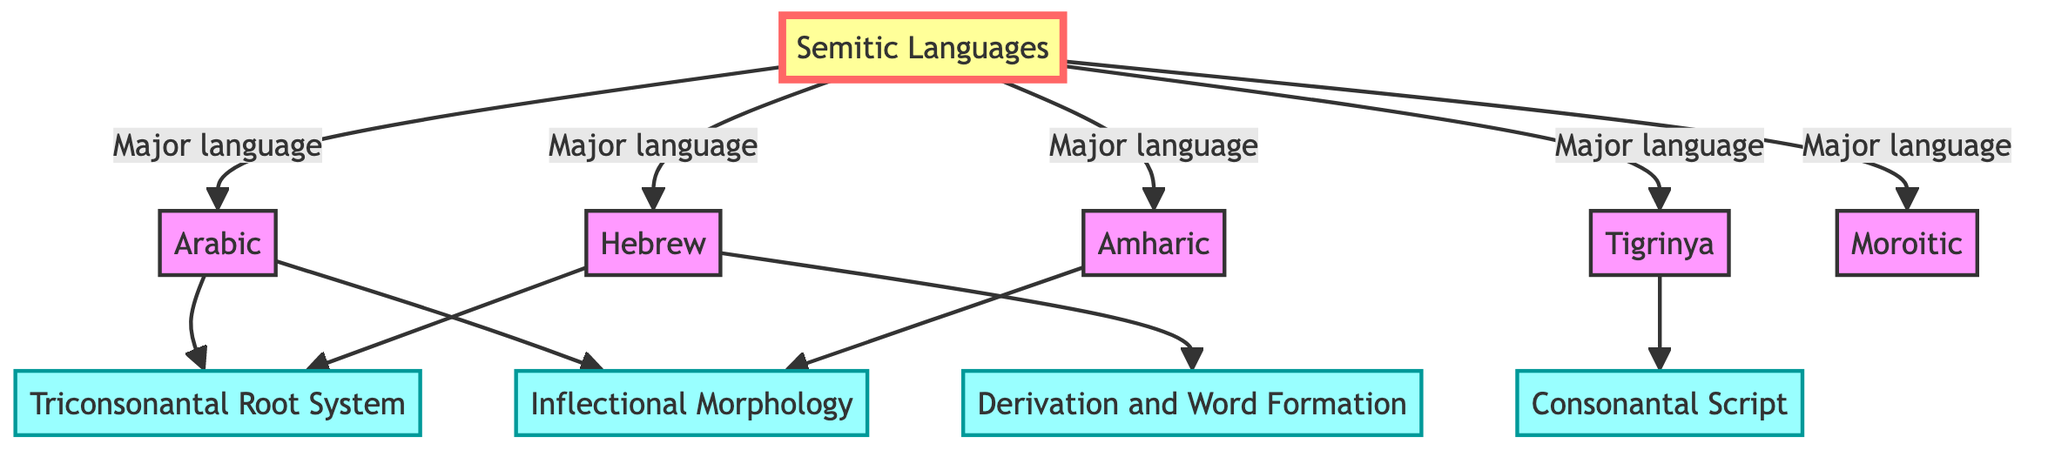What are the major Semitic languages depicted in the graph? The graph shows five major Semitic languages connected to the "Semitic Languages" root node: Arabic, Hebrew, Amharic, Tigrinya, and Moroitic.
Answer: Arabic, Hebrew, Amharic, Tigrinya, Moroitic How many languages are directly connected to the root node? By counting the edges emanating from the "Semitic Languages" node, we identify five connections leading to the language nodes.
Answer: 5 Which language is connected to both Triconsonantal Root System and Inflectional Morphology? Examining the connections, Arabic is linked to both the Triconsonantal Root System and Inflectional Morphology, indicated by two outgoing edges from Arabic.
Answer: Arabic Which linguistic feature does Tigrinya exhibit according to the diagram? Tigrinya has an outgoing connection to the Consonantal Script node, indicating it exhibits this linguistic feature.
Answer: Consonantal Script Are there any common linguistic features shared between Hebrew and Arabic? Hebrew and Arabic both exhibit the Triconsonantal Root System as a common feature, represented by their connections to the same node.
Answer: Triconsonantal Root System How does Amharic differ from Tigrinya in terms of shared linguistic features? While Amharic has a connection to Inflectional Morphology, Tigrinya is linked to Consonantal Script, indicating they share different linguistic features.
Answer: Inflectional Morphology, Consonantal Script What type of linguistic morphology is associated with both Arabic and Amharic? Both languages are linked to Inflectional Morphology, indicating that this type of morphological structure is related to both.
Answer: Inflectional Morphology What is the relationship between Hebrew and Derivation and Word Formation? The graph shows a direct edge from the Hebrew node to the Derivation and Word Formation node, indicating a specific linguistic relationship.
Answer: Derivation and Word Formation Which Semitic language is exclusively connected to the feature of Inflectional Morphology? The only language connected solely to Inflectional Morphology is Amharic, as it does not share this connection with other languages in the graph.
Answer: Amharic 